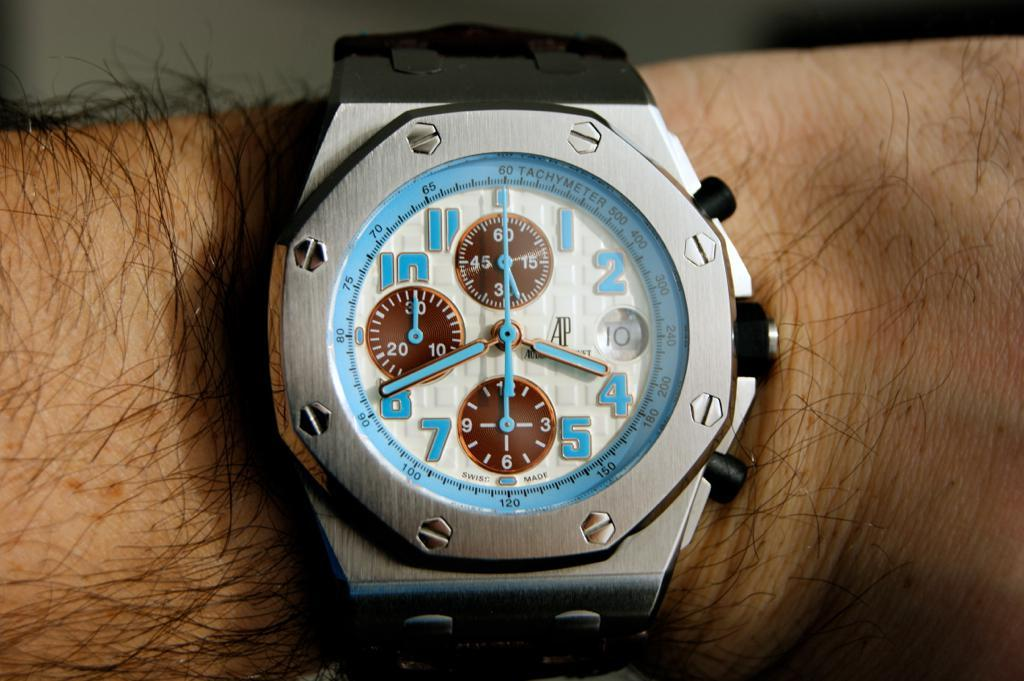<image>
Give a short and clear explanation of the subsequent image. A watch face displays 4:40 on its face. 